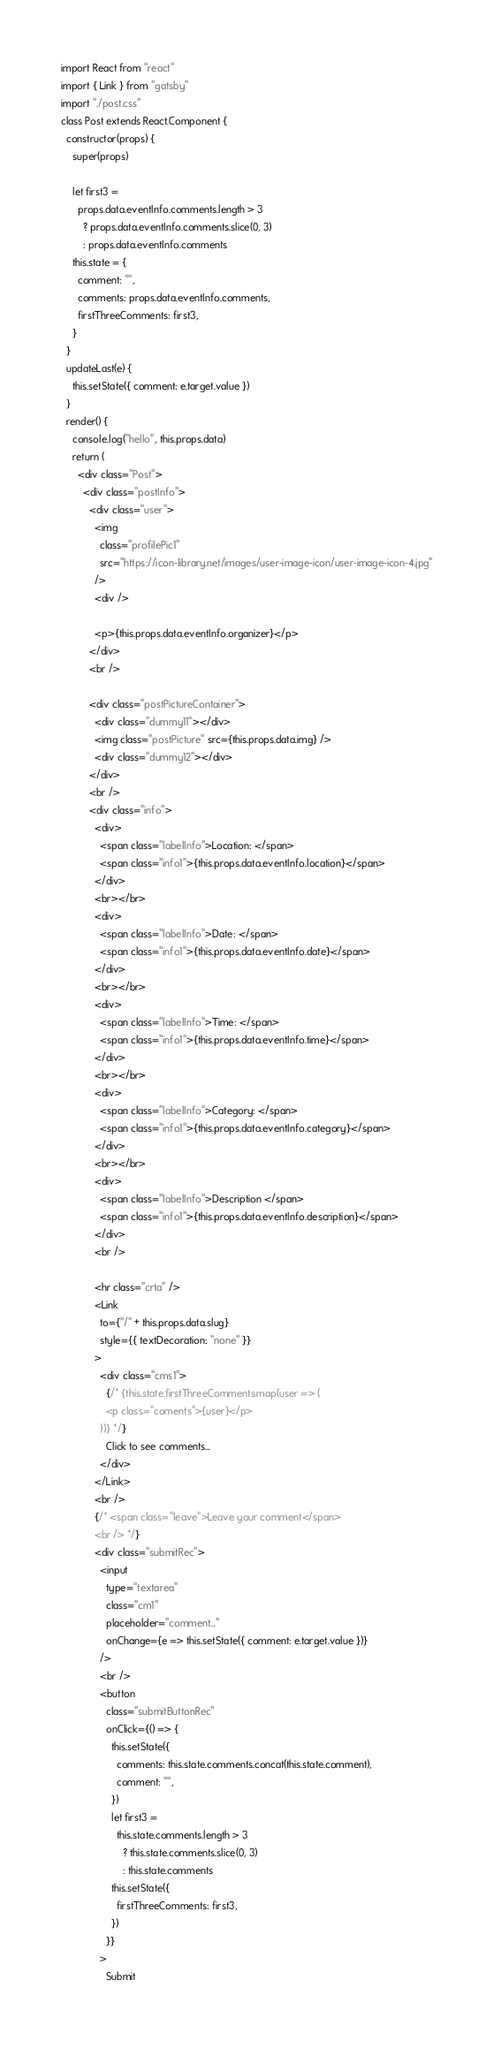Convert code to text. <code><loc_0><loc_0><loc_500><loc_500><_JavaScript_>import React from "react"
import { Link } from "gatsby"
import "./post.css"
class Post extends React.Component {
  constructor(props) {
    super(props)

    let first3 =
      props.data.eventInfo.comments.length > 3
        ? props.data.eventInfo.comments.slice(0, 3)
        : props.data.eventInfo.comments
    this.state = {
      comment: "",
      comments: props.data.eventInfo.comments,
      firstThreeComments: first3,
    }
  }
  updateLast(e) {
    this.setState({ comment: e.target.value })
  }
  render() {
    console.log("hello", this.props.data)
    return (
      <div class="Post">
        <div class="postInfo">
          <div class="user">
            <img
              class="profilePic1"
              src="https://icon-library.net/images/user-image-icon/user-image-icon-4.jpg"
            />
            <div />

            <p>{this.props.data.eventInfo.organizer}</p>
          </div>
          <br />

          <div class="postPictureContainer">
            <div class="dummy11"></div>
            <img class="postPicture" src={this.props.data.img} />
            <div class="dummy12"></div>
          </div>
          <br />
          <div class="info">
            <div>
              <span class="labelInfo">Location: </span>
              <span class="info1">{this.props.data.eventInfo.location}</span>
            </div>
            <br></br>
            <div>
              <span class="labelInfo">Date: </span>
              <span class="info1">{this.props.data.eventInfo.date}</span>
            </div>
            <br></br>
            <div>
              <span class="labelInfo">Time: </span>
              <span class="info1">{this.props.data.eventInfo.time}</span>
            </div>
            <br></br>
            <div>
              <span class="labelInfo">Category: </span>
              <span class="info1">{this.props.data.eventInfo.category}</span>
            </div>
            <br></br>
            <div>
              <span class="labelInfo">Description </span>
              <span class="info1">{this.props.data.eventInfo.description}</span>
            </div>
            <br />

            <hr class="crta" />
            <Link
              to={"/" + this.props.data.slug}
              style={{ textDecoration: "none" }}
            >
              <div class="cms1">
                {/* {this.state.firstThreeComments.map(user => (
                <p class="coments">{user}</p>
              ))} */}
                Click to see comments...
              </div>
            </Link>
            <br />
            {/* <span class="leave">Leave your comment</span>
            <br /> */}
            <div class="submitRec">
              <input
                type="textarea"
                class="cm1"
                placeholder="comment..."
                onChange={e => this.setState({ comment: e.target.value })}
              />
              <br />
              <button
                class="submitButtonRec"
                onClick={() => {
                  this.setState({
                    comments: this.state.comments.concat(this.state.comment),
                    comment: "",
                  })
                  let first3 =
                    this.state.comments.length > 3
                      ? this.state.comments.slice(0, 3)
                      : this.state.comments
                  this.setState({
                    firstThreeComments: first3,
                  })
                }}
              >
                Submit</code> 